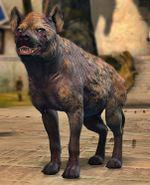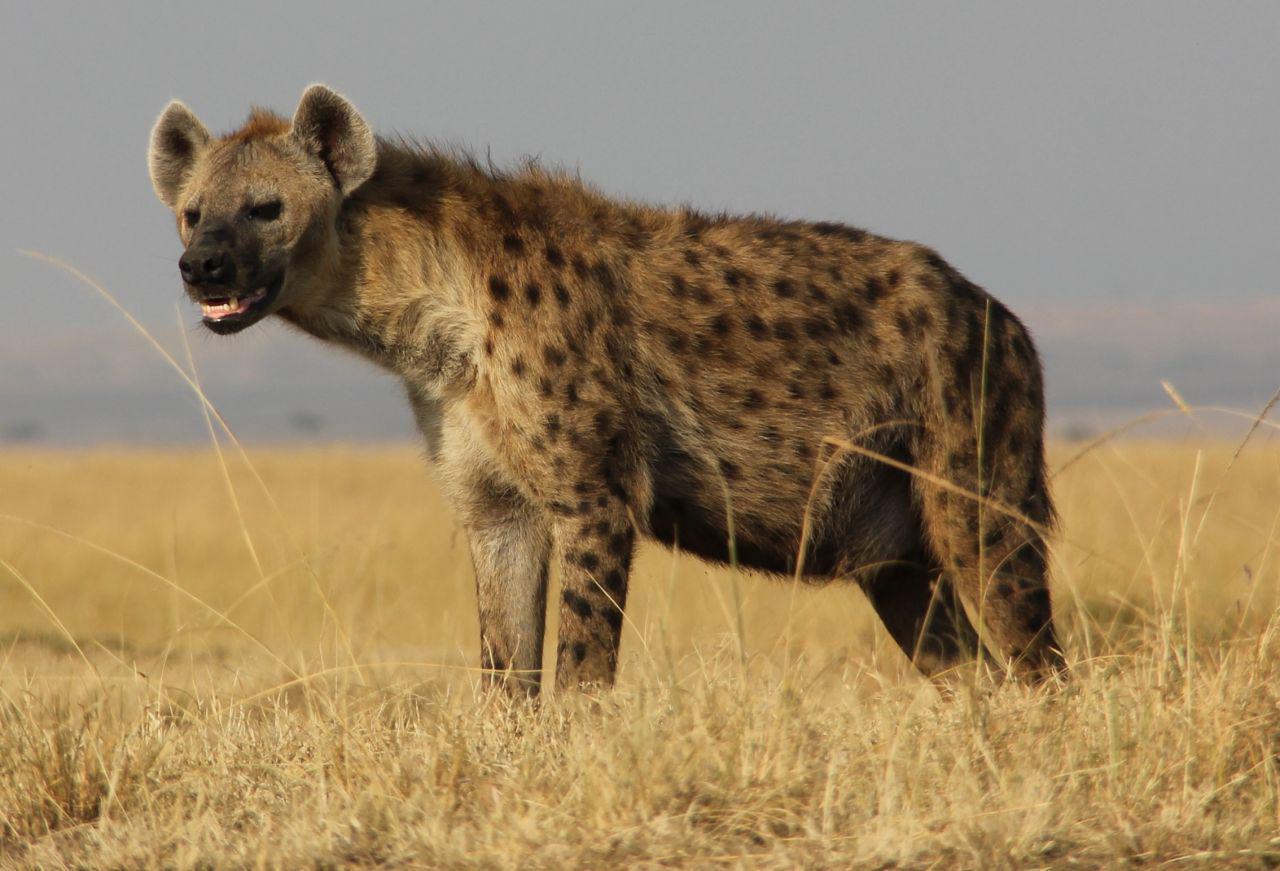The first image is the image on the left, the second image is the image on the right. Evaluate the accuracy of this statement regarding the images: "There is only one hyena that is standing in each image.". Is it true? Answer yes or no. Yes. The first image is the image on the left, the second image is the image on the right. For the images displayed, is the sentence "Each image contains one hyena, and the hyena on the right has its head and body turned mostly forward, with its neck not raised higher than its shoulders." factually correct? Answer yes or no. No. 